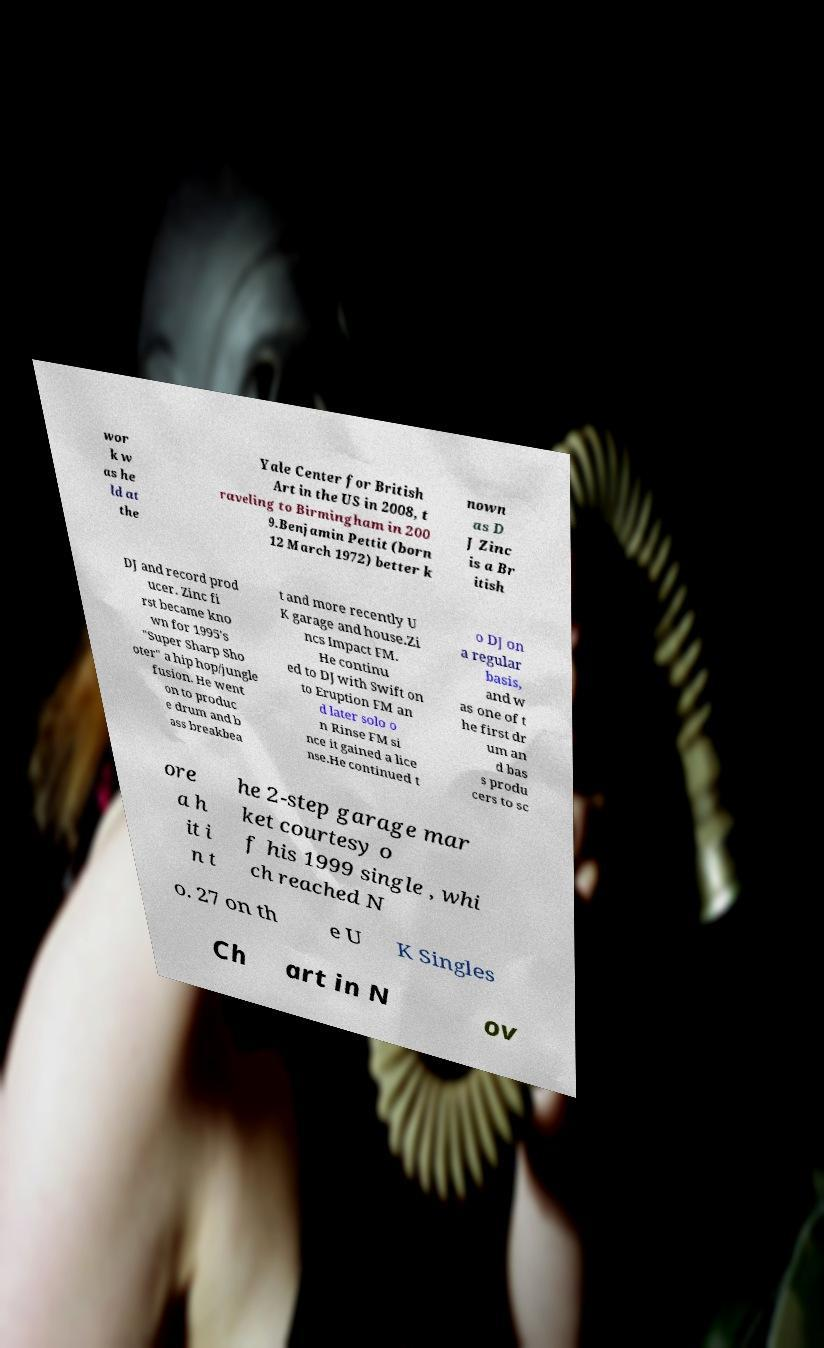Can you accurately transcribe the text from the provided image for me? wor k w as he ld at the Yale Center for British Art in the US in 2008, t raveling to Birmingham in 200 9.Benjamin Pettit (born 12 March 1972) better k nown as D J Zinc is a Br itish DJ and record prod ucer. Zinc fi rst became kno wn for 1995's "Super Sharp Sho oter" a hip hop/jungle fusion. He went on to produc e drum and b ass breakbea t and more recently U K garage and house.Zi ncs Impact FM. He continu ed to DJ with Swift on to Eruption FM an d later solo o n Rinse FM si nce it gained a lice nse.He continued t o DJ on a regular basis, and w as one of t he first dr um an d bas s produ cers to sc ore a h it i n t he 2-step garage mar ket courtesy o f his 1999 single , whi ch reached N o. 27 on th e U K Singles Ch art in N ov 